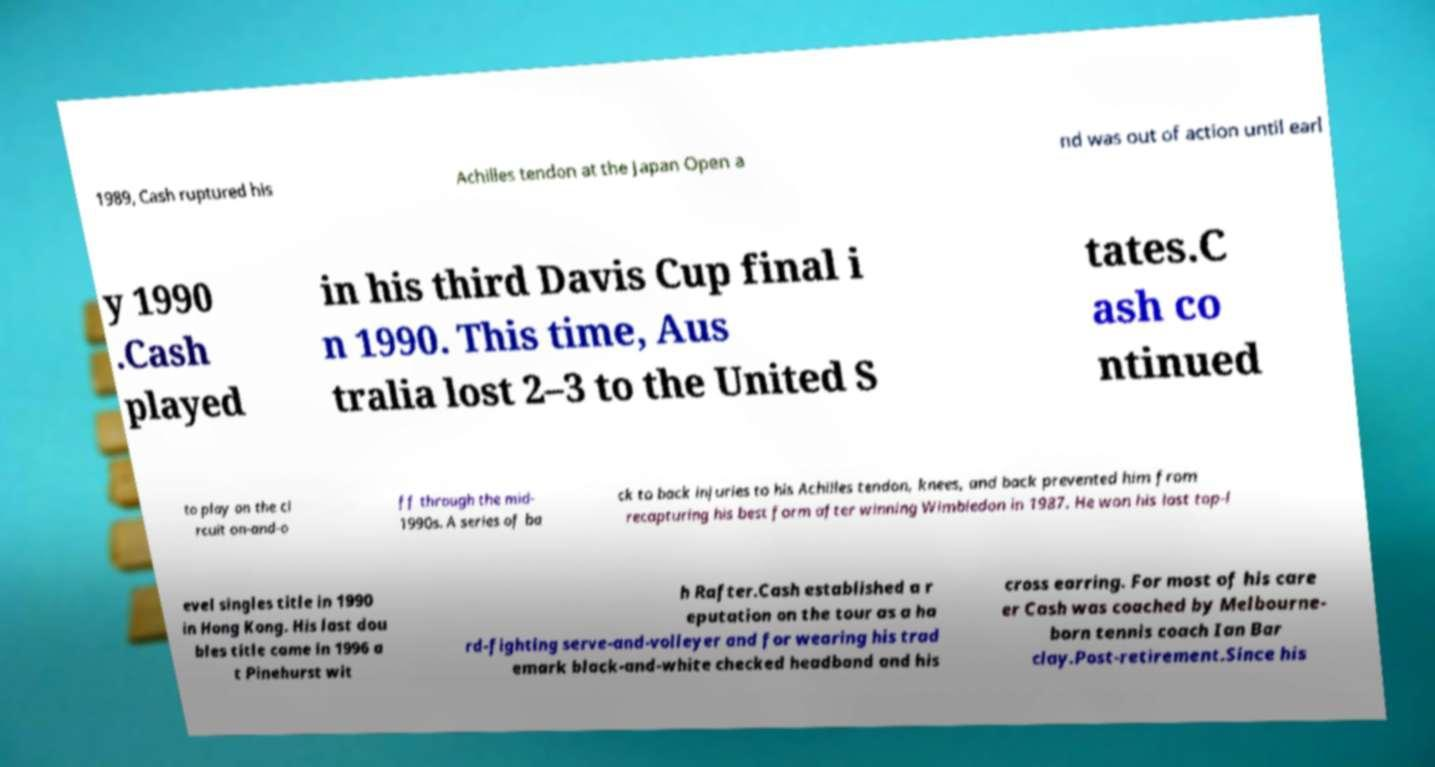I need the written content from this picture converted into text. Can you do that? 1989, Cash ruptured his Achilles tendon at the Japan Open a nd was out of action until earl y 1990 .Cash played in his third Davis Cup final i n 1990. This time, Aus tralia lost 2–3 to the United S tates.C ash co ntinued to play on the ci rcuit on-and-o ff through the mid- 1990s. A series of ba ck to back injuries to his Achilles tendon, knees, and back prevented him from recapturing his best form after winning Wimbledon in 1987. He won his last top-l evel singles title in 1990 in Hong Kong. His last dou bles title came in 1996 a t Pinehurst wit h Rafter.Cash established a r eputation on the tour as a ha rd-fighting serve-and-volleyer and for wearing his trad emark black-and-white checked headband and his cross earring. For most of his care er Cash was coached by Melbourne- born tennis coach Ian Bar clay.Post-retirement.Since his 